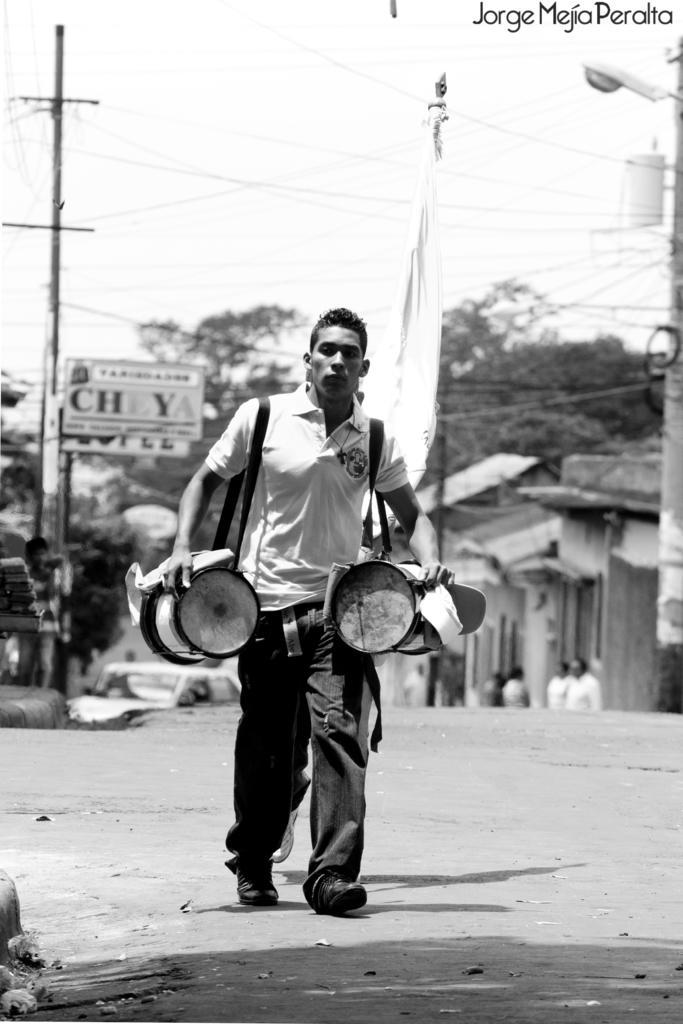Please provide a concise description of this image. This is a black and white picture, a man is walking on a road. The man is holding a music instruments. Background of this man there is a pillar, board and trees. On the right side of the man there is other pillar to the pillar there is a light, street light. 